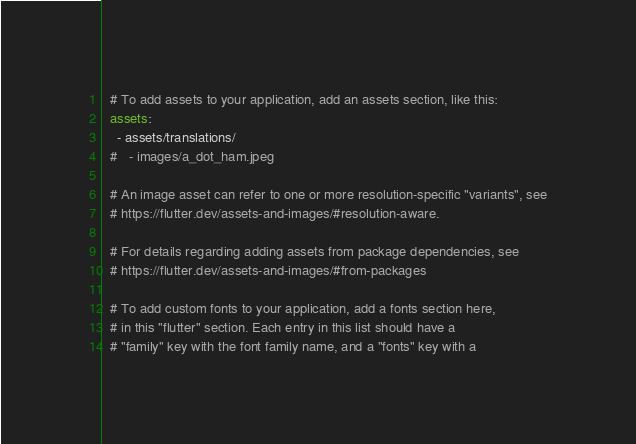Convert code to text. <code><loc_0><loc_0><loc_500><loc_500><_YAML_>  # To add assets to your application, add an assets section, like this:
  assets:
    - assets/translations/
  #   - images/a_dot_ham.jpeg

  # An image asset can refer to one or more resolution-specific "variants", see
  # https://flutter.dev/assets-and-images/#resolution-aware.

  # For details regarding adding assets from package dependencies, see
  # https://flutter.dev/assets-and-images/#from-packages

  # To add custom fonts to your application, add a fonts section here,
  # in this "flutter" section. Each entry in this list should have a
  # "family" key with the font family name, and a "fonts" key with a</code> 